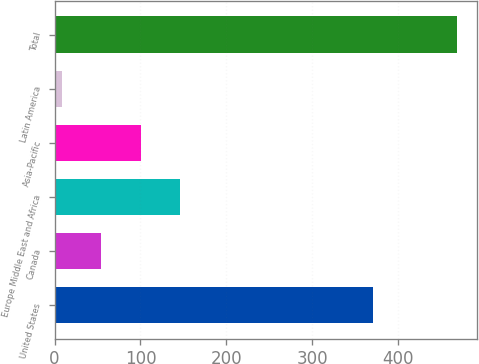Convert chart. <chart><loc_0><loc_0><loc_500><loc_500><bar_chart><fcel>United States<fcel>Canada<fcel>Europe Middle East and Africa<fcel>Asia-Pacific<fcel>Latin America<fcel>Total<nl><fcel>370.8<fcel>54.32<fcel>146.36<fcel>100.34<fcel>8.3<fcel>468.5<nl></chart> 